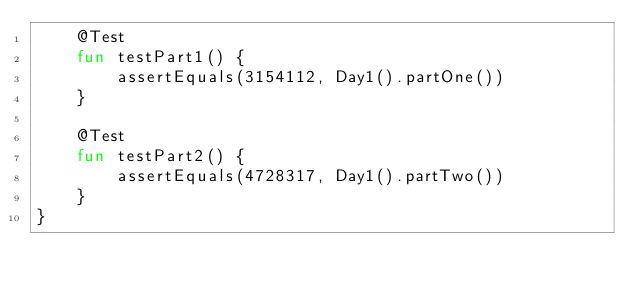Convert code to text. <code><loc_0><loc_0><loc_500><loc_500><_Kotlin_>    @Test
    fun testPart1() {
        assertEquals(3154112, Day1().partOne())
    }

    @Test
    fun testPart2() {
        assertEquals(4728317, Day1().partTwo())
    }
}</code> 